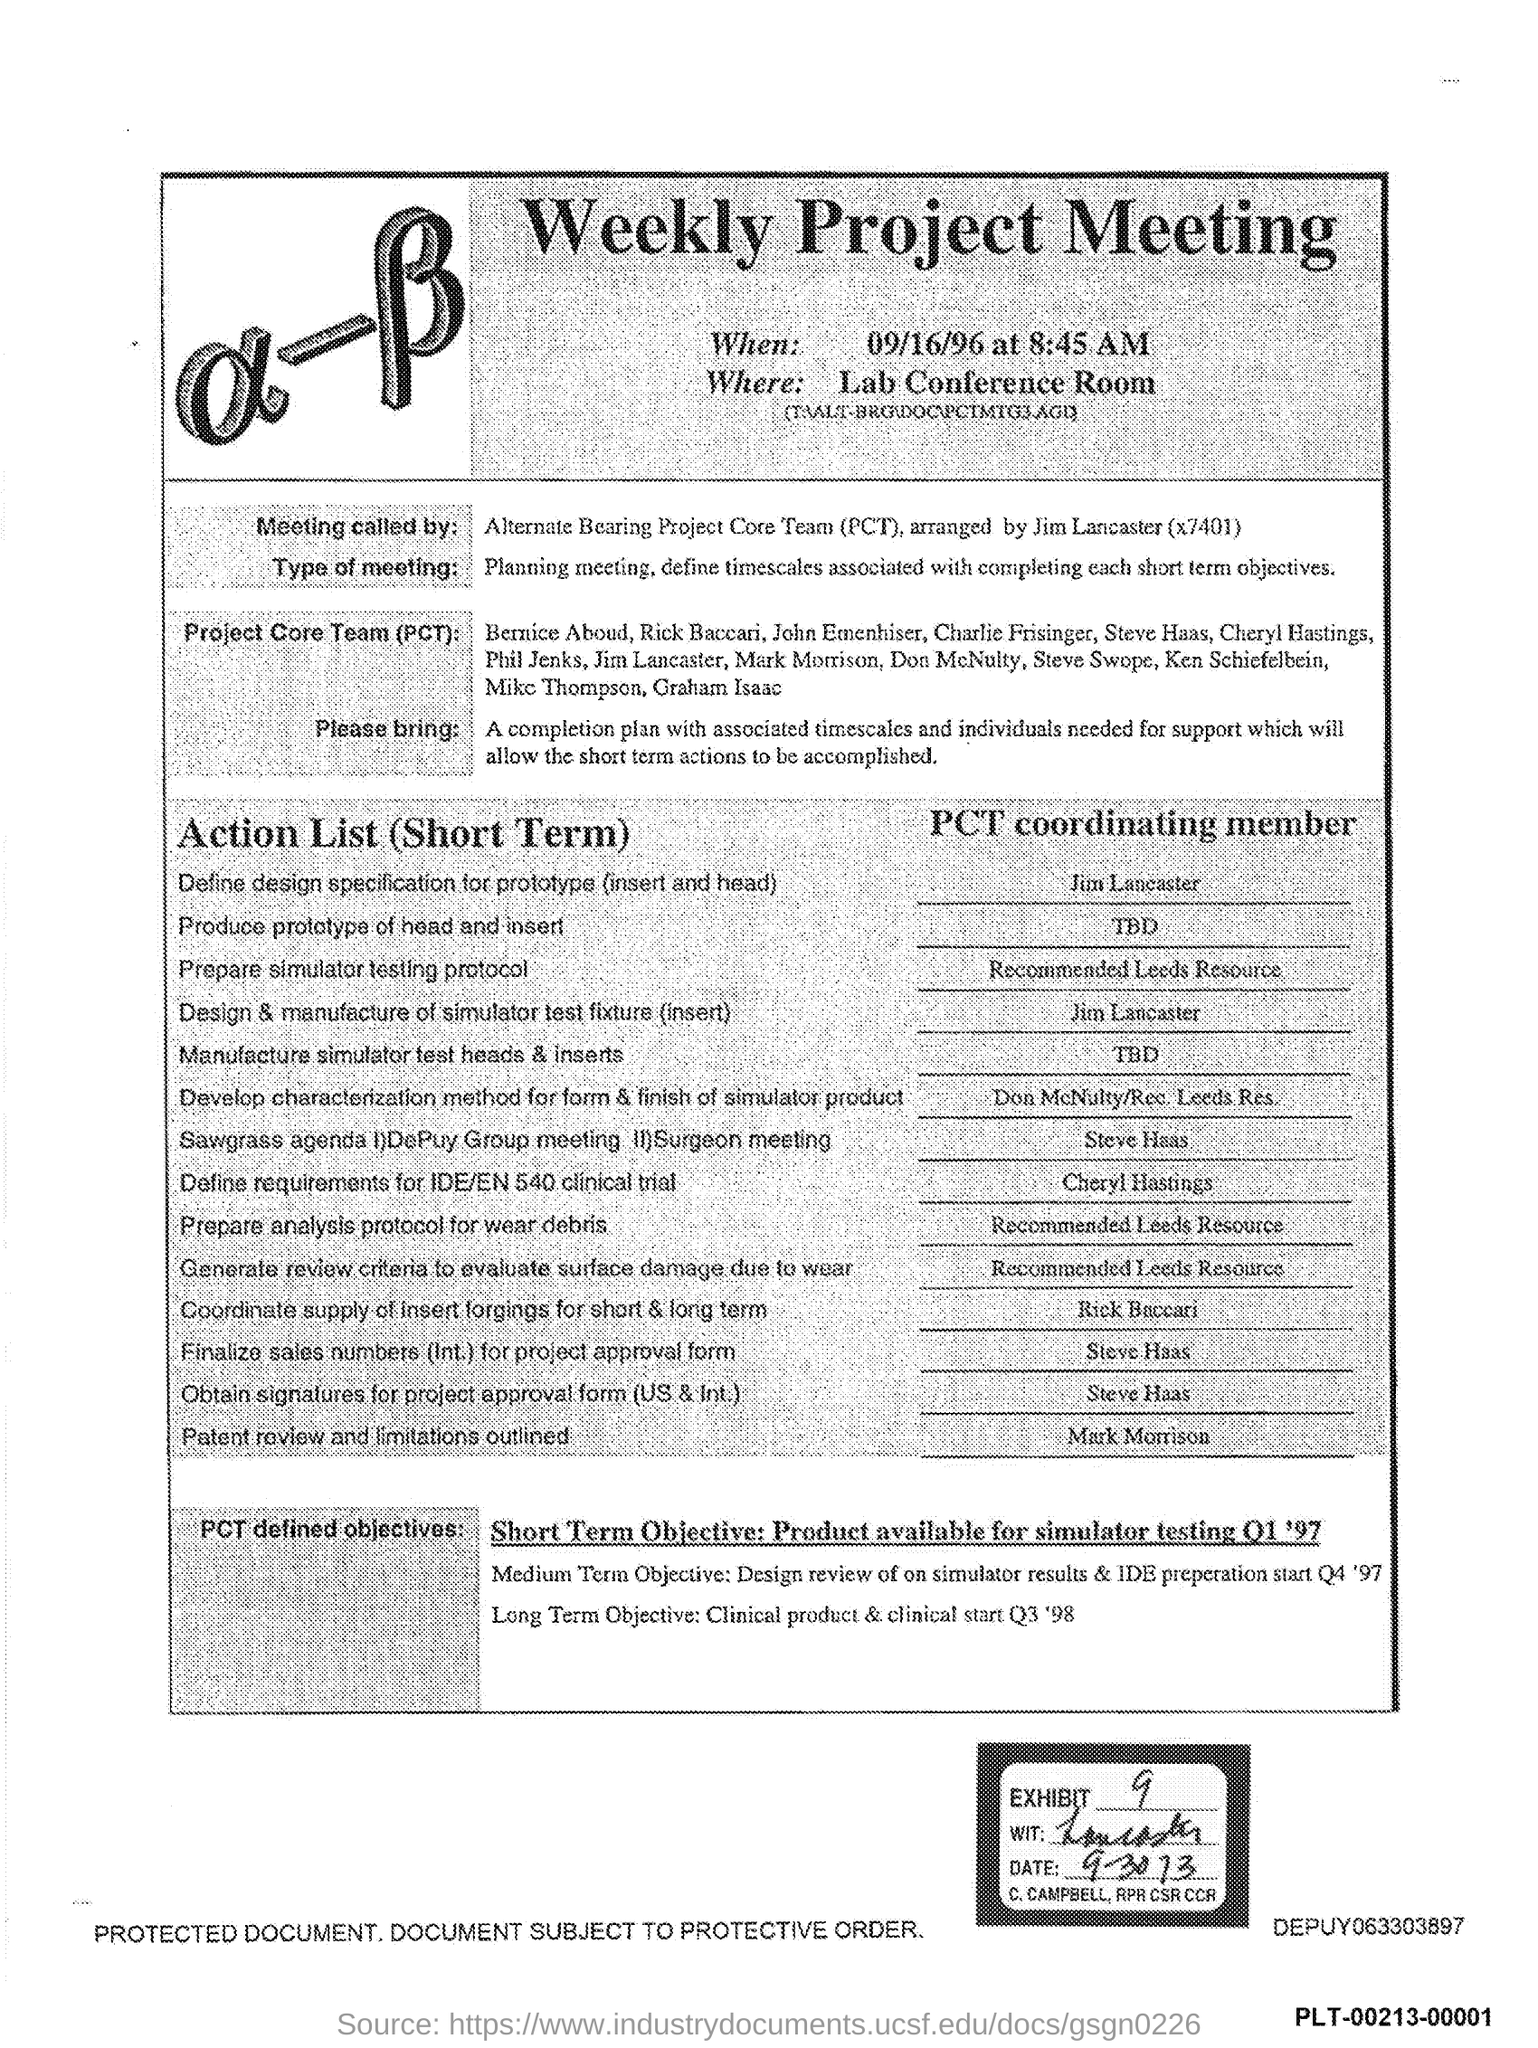What is the Exhibit number?
Ensure brevity in your answer.  9. Weekly project meeting is organized in which room?
Make the answer very short. Lab Conference room. What is the title of the document?
Provide a short and direct response. Weekly project meeting. 